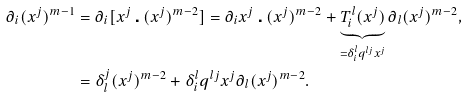Convert formula to latex. <formula><loc_0><loc_0><loc_500><loc_500>\partial _ { i } ( x ^ { j } ) ^ { m - 1 } & = \partial _ { i } [ x ^ { j } \centerdot ( x ^ { j } ) ^ { m - 2 } ] = \partial _ { i } x ^ { j } \centerdot ( x ^ { j } ) ^ { m - 2 } + \underbrace { T ^ { l } _ { i } ( x ^ { j } ) } _ { = \delta ^ { l } _ { i } q ^ { l j } x ^ { j } } \partial _ { l } ( x ^ { j } ) ^ { m - 2 } , \\ & = \delta ^ { j } _ { l } ( x ^ { j } ) ^ { m - 2 } + \delta ^ { l } _ { i } q ^ { l j } x ^ { j } \partial _ { l } ( x ^ { j } ) ^ { m - 2 } .</formula> 